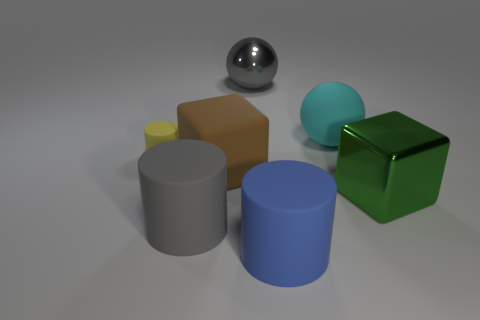Is the gray rubber thing the same shape as the yellow thing?
Offer a terse response. Yes. What number of things are either big cubes in front of the brown cube or large red metal things?
Give a very brief answer. 1. Are there the same number of big blue matte things in front of the yellow rubber thing and large gray things on the right side of the large green metallic object?
Make the answer very short. No. How many other things are there of the same shape as the large green shiny object?
Your response must be concise. 1. Do the block that is on the left side of the cyan matte thing and the cube that is to the right of the large cyan rubber thing have the same size?
Give a very brief answer. Yes. How many cylinders are either yellow rubber things or big gray metal objects?
Keep it short and to the point. 1. What number of metallic things are gray cylinders or tiny green spheres?
Make the answer very short. 0. There is a green object that is the same shape as the big brown matte thing; what is its size?
Your response must be concise. Large. Is there any other thing that has the same size as the brown thing?
Provide a short and direct response. Yes. There is a cyan thing; is it the same size as the rubber cylinder to the left of the gray matte cylinder?
Ensure brevity in your answer.  No. 